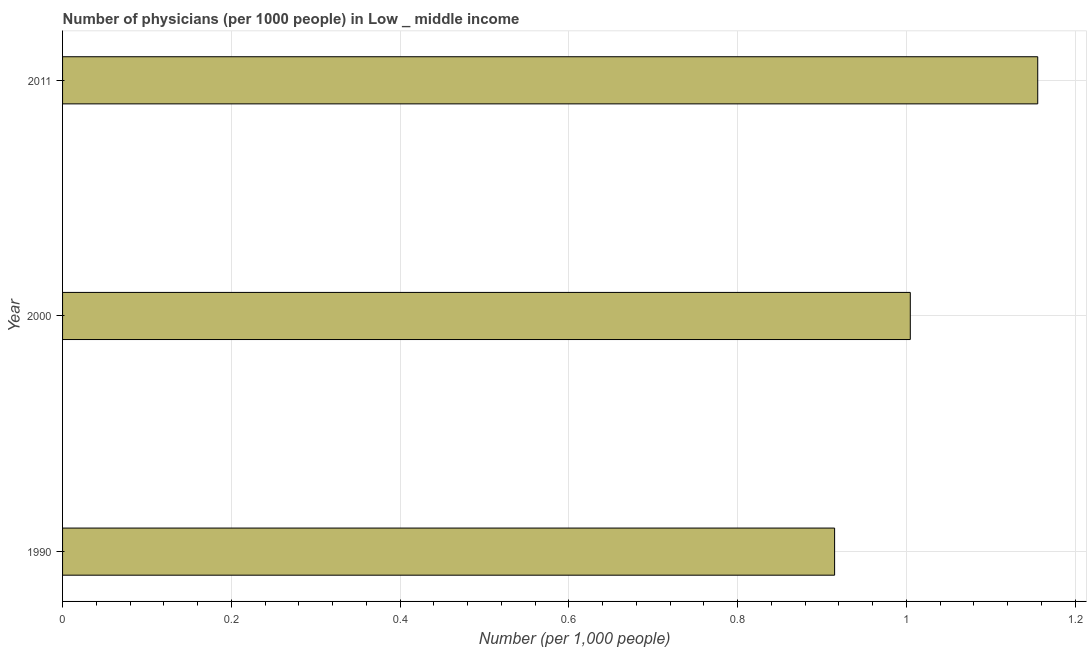Does the graph contain any zero values?
Provide a succinct answer. No. What is the title of the graph?
Make the answer very short. Number of physicians (per 1000 people) in Low _ middle income. What is the label or title of the X-axis?
Offer a terse response. Number (per 1,0 people). What is the label or title of the Y-axis?
Make the answer very short. Year. What is the number of physicians in 2011?
Keep it short and to the point. 1.16. Across all years, what is the maximum number of physicians?
Keep it short and to the point. 1.16. Across all years, what is the minimum number of physicians?
Provide a short and direct response. 0.91. In which year was the number of physicians maximum?
Ensure brevity in your answer.  2011. In which year was the number of physicians minimum?
Make the answer very short. 1990. What is the sum of the number of physicians?
Your answer should be very brief. 3.08. What is the difference between the number of physicians in 2000 and 2011?
Offer a very short reply. -0.15. What is the average number of physicians per year?
Keep it short and to the point. 1.02. What is the median number of physicians?
Keep it short and to the point. 1. Do a majority of the years between 1990 and 2011 (inclusive) have number of physicians greater than 0.28 ?
Offer a very short reply. Yes. What is the ratio of the number of physicians in 1990 to that in 2011?
Offer a terse response. 0.79. Is the difference between the number of physicians in 1990 and 2000 greater than the difference between any two years?
Your answer should be compact. No. What is the difference between the highest and the second highest number of physicians?
Offer a very short reply. 0.15. Is the sum of the number of physicians in 2000 and 2011 greater than the maximum number of physicians across all years?
Offer a terse response. Yes. What is the difference between the highest and the lowest number of physicians?
Provide a succinct answer. 0.24. How many bars are there?
Your response must be concise. 3. Are all the bars in the graph horizontal?
Ensure brevity in your answer.  Yes. How many years are there in the graph?
Give a very brief answer. 3. What is the Number (per 1,000 people) in 1990?
Your response must be concise. 0.91. What is the Number (per 1,000 people) of 2000?
Give a very brief answer. 1. What is the Number (per 1,000 people) of 2011?
Your answer should be very brief. 1.16. What is the difference between the Number (per 1,000 people) in 1990 and 2000?
Your answer should be very brief. -0.09. What is the difference between the Number (per 1,000 people) in 1990 and 2011?
Offer a very short reply. -0.24. What is the difference between the Number (per 1,000 people) in 2000 and 2011?
Provide a succinct answer. -0.15. What is the ratio of the Number (per 1,000 people) in 1990 to that in 2000?
Provide a short and direct response. 0.91. What is the ratio of the Number (per 1,000 people) in 1990 to that in 2011?
Provide a succinct answer. 0.79. What is the ratio of the Number (per 1,000 people) in 2000 to that in 2011?
Provide a succinct answer. 0.87. 